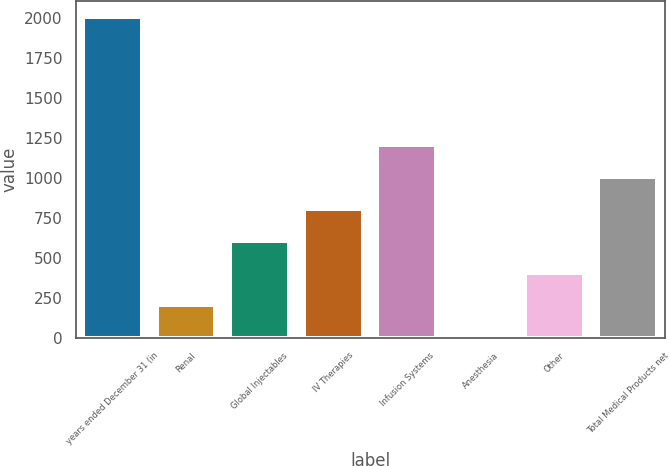Convert chart. <chart><loc_0><loc_0><loc_500><loc_500><bar_chart><fcel>years ended December 31 (in<fcel>Renal<fcel>Global Injectables<fcel>IV Therapies<fcel>Infusion Systems<fcel>Anesthesia<fcel>Other<fcel>Total Medical Products net<nl><fcel>2011<fcel>202<fcel>604<fcel>805<fcel>1207<fcel>1<fcel>403<fcel>1006<nl></chart> 